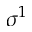<formula> <loc_0><loc_0><loc_500><loc_500>\sigma ^ { 1 }</formula> 